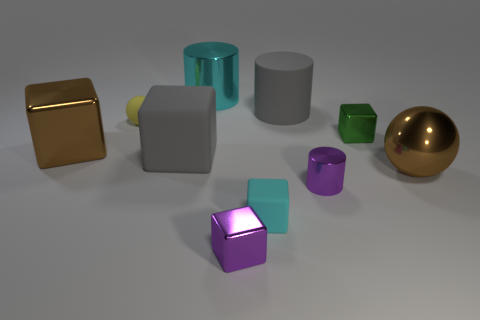Subtract all green cubes. How many cubes are left? 4 Subtract all big gray rubber cubes. How many cubes are left? 4 Subtract all yellow blocks. Subtract all cyan cylinders. How many blocks are left? 5 Subtract all balls. How many objects are left? 8 Add 7 big purple matte balls. How many big purple matte balls exist? 7 Subtract 0 yellow cylinders. How many objects are left? 10 Subtract all yellow matte things. Subtract all small shiny cylinders. How many objects are left? 8 Add 2 large cyan cylinders. How many large cyan cylinders are left? 3 